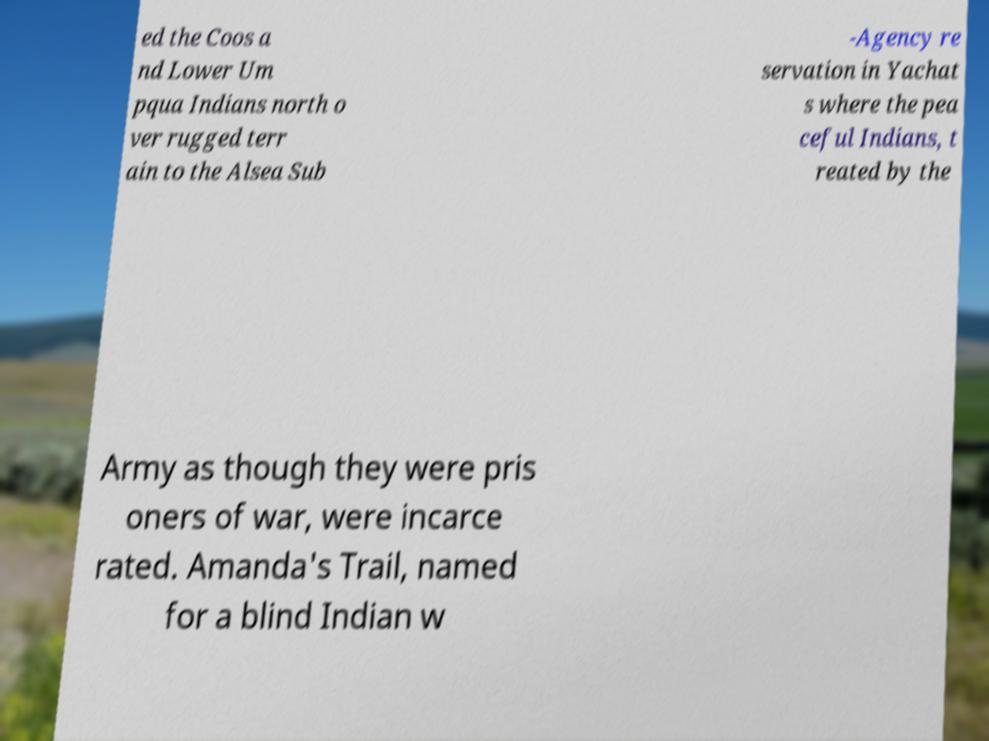Please read and relay the text visible in this image. What does it say? ed the Coos a nd Lower Um pqua Indians north o ver rugged terr ain to the Alsea Sub -Agency re servation in Yachat s where the pea ceful Indians, t reated by the Army as though they were pris oners of war, were incarce rated. Amanda's Trail, named for a blind Indian w 